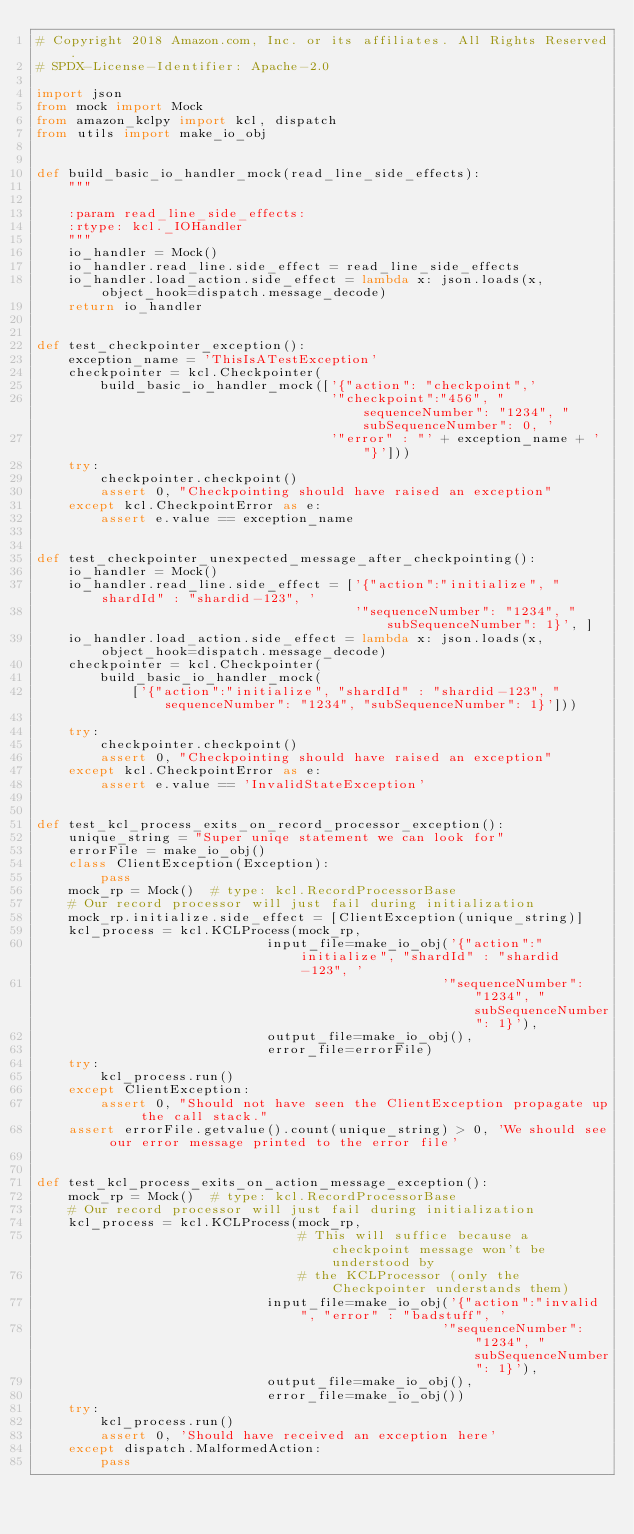<code> <loc_0><loc_0><loc_500><loc_500><_Python_># Copyright 2018 Amazon.com, Inc. or its affiliates. All Rights Reserved.
# SPDX-License-Identifier: Apache-2.0

import json
from mock import Mock
from amazon_kclpy import kcl, dispatch
from utils import make_io_obj


def build_basic_io_handler_mock(read_line_side_effects):
    """

    :param read_line_side_effects:
    :rtype: kcl._IOHandler
    """
    io_handler = Mock()
    io_handler.read_line.side_effect = read_line_side_effects
    io_handler.load_action.side_effect = lambda x: json.loads(x, object_hook=dispatch.message_decode)
    return io_handler


def test_checkpointer_exception():
    exception_name = 'ThisIsATestException'
    checkpointer = kcl.Checkpointer(
        build_basic_io_handler_mock(['{"action": "checkpoint",'
                                     '"checkpoint":"456", "sequenceNumber": "1234", "subSequenceNumber": 0, '
                                     '"error" : "' + exception_name + '"}']))
    try:
        checkpointer.checkpoint()
        assert 0, "Checkpointing should have raised an exception"
    except kcl.CheckpointError as e:
        assert e.value == exception_name


def test_checkpointer_unexpected_message_after_checkpointing():
    io_handler = Mock()
    io_handler.read_line.side_effect = ['{"action":"initialize", "shardId" : "shardid-123", '
                                        '"sequenceNumber": "1234", "subSequenceNumber": 1}', ]
    io_handler.load_action.side_effect = lambda x: json.loads(x, object_hook=dispatch.message_decode)
    checkpointer = kcl.Checkpointer(
        build_basic_io_handler_mock(
            ['{"action":"initialize", "shardId" : "shardid-123", "sequenceNumber": "1234", "subSequenceNumber": 1}']))

    try:
        checkpointer.checkpoint()
        assert 0, "Checkpointing should have raised an exception"
    except kcl.CheckpointError as e:
        assert e.value == 'InvalidStateException'


def test_kcl_process_exits_on_record_processor_exception():
    unique_string = "Super uniqe statement we can look for"
    errorFile = make_io_obj()
    class ClientException(Exception):
        pass
    mock_rp = Mock()  # type: kcl.RecordProcessorBase
    # Our record processor will just fail during initialization
    mock_rp.initialize.side_effect = [ClientException(unique_string)]
    kcl_process = kcl.KCLProcess(mock_rp,
                             input_file=make_io_obj('{"action":"initialize", "shardId" : "shardid-123", '
                                                   '"sequenceNumber": "1234", "subSequenceNumber": 1}'),
                             output_file=make_io_obj(),
                             error_file=errorFile)
    try:
        kcl_process.run()
    except ClientException:
        assert 0, "Should not have seen the ClientException propagate up the call stack."
    assert errorFile.getvalue().count(unique_string) > 0, 'We should see our error message printed to the error file'


def test_kcl_process_exits_on_action_message_exception():
    mock_rp = Mock()  # type: kcl.RecordProcessorBase
    # Our record processor will just fail during initialization
    kcl_process = kcl.KCLProcess(mock_rp,
                                 # This will suffice because a checkpoint message won't be understood by
                                 # the KCLProcessor (only the Checkpointer understands them)
                             input_file=make_io_obj('{"action":"invalid", "error" : "badstuff", '
                                                   '"sequenceNumber": "1234", "subSequenceNumber": 1}'),
                             output_file=make_io_obj(),
                             error_file=make_io_obj())
    try:
        kcl_process.run()
        assert 0, 'Should have received an exception here'
    except dispatch.MalformedAction:
        pass

</code> 